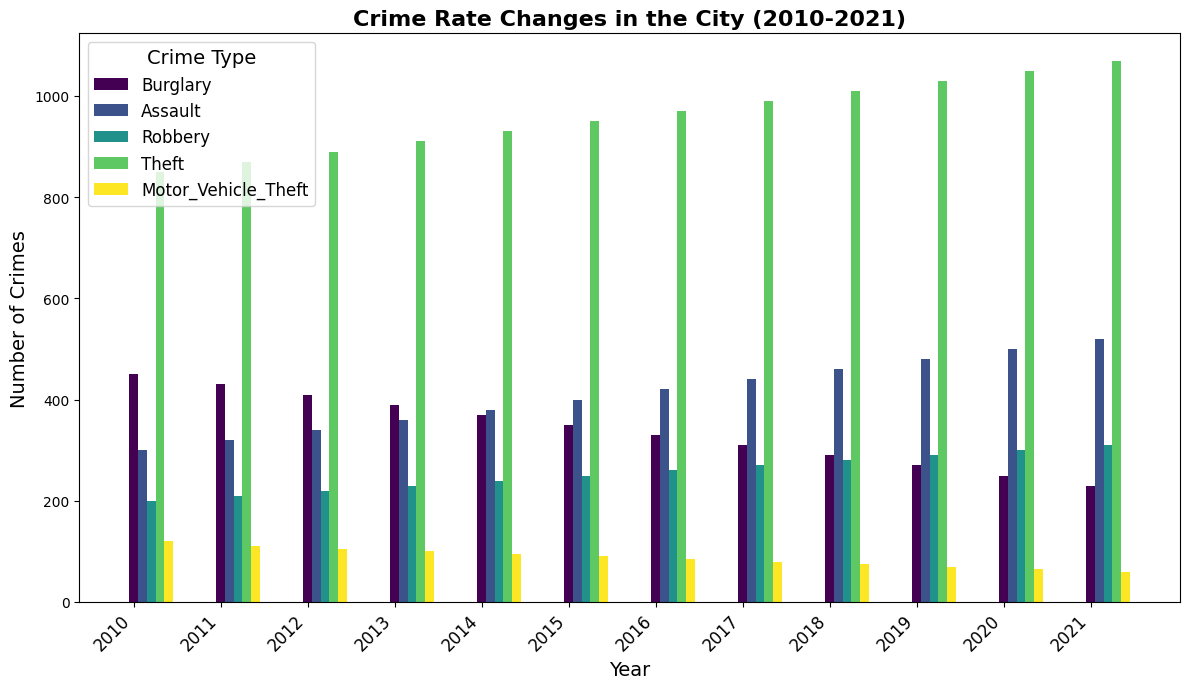What was the trend in burglary rates from 2010 to 2021? To find the trend in burglary rates, observe the heights of the bars representing burglary from 2010 to 2021. Note how the bar heights decrease each year, indicating a decreasing trend.
Answer: Decreasing In which year did motor vehicle thefts reach their lowest point? By examining the heights of the bars representing motor vehicle thefts across all years, it's evident that the shortest bar appears in 2021.
Answer: 2021 Which crime type showed an increase in occurrences every year? Compare the bar heights of every year for each crime type. Notice that for assault, the bar height steadily increases from 2010 to 2021.
Answer: Assault What was the total number of thefts recorded over the years 2017, 2018, and 2019? Sum the bar heights of theft for the years 2017, 2018, and 2019. The heights are 990, 1010, and 1030 respectively. Adding 990 + 1010 + 1030 gives 3030.
Answer: 3030 How does the height of the 2020 robbery bar compare to the height of the 2010 robbery bar? Observe the bars for robbery in 2010 and 2020. The 2020 bar is significantly taller than the 2010 bar, indicating more robberies in 2020 compared to 2010.
Answer: 2020 is higher Which crime type had the most significant increase from 2010 to 2021? Calculate the difference in bar heights for each crime type between 2010 and 2021. Assault increased from 300 to 520, an increase of 220, which is the largest compared to others.
Answer: Assault What is the average number of burglaries between 2010 and 2021? Sum the burglary counts from 2010 to 2021 (450, 430, 410, 390, 370, 350, 330, 310, 290, 270, 250, 230) and divide by 12. The total is 4090. 4090/12 = 340.83.
Answer: 340.83 Which year had the highest total number of crimes? Calculate the sum of crime counts for each year. Compare each year's total. The year with the highest sum is 2021.
Answer: 2021 How many more assaults were there in 2021 compared to 2010? Subtract the number of assaults in 2010 (300) from the number in 2021 (520). 520 - 300 = 220.
Answer: 220 